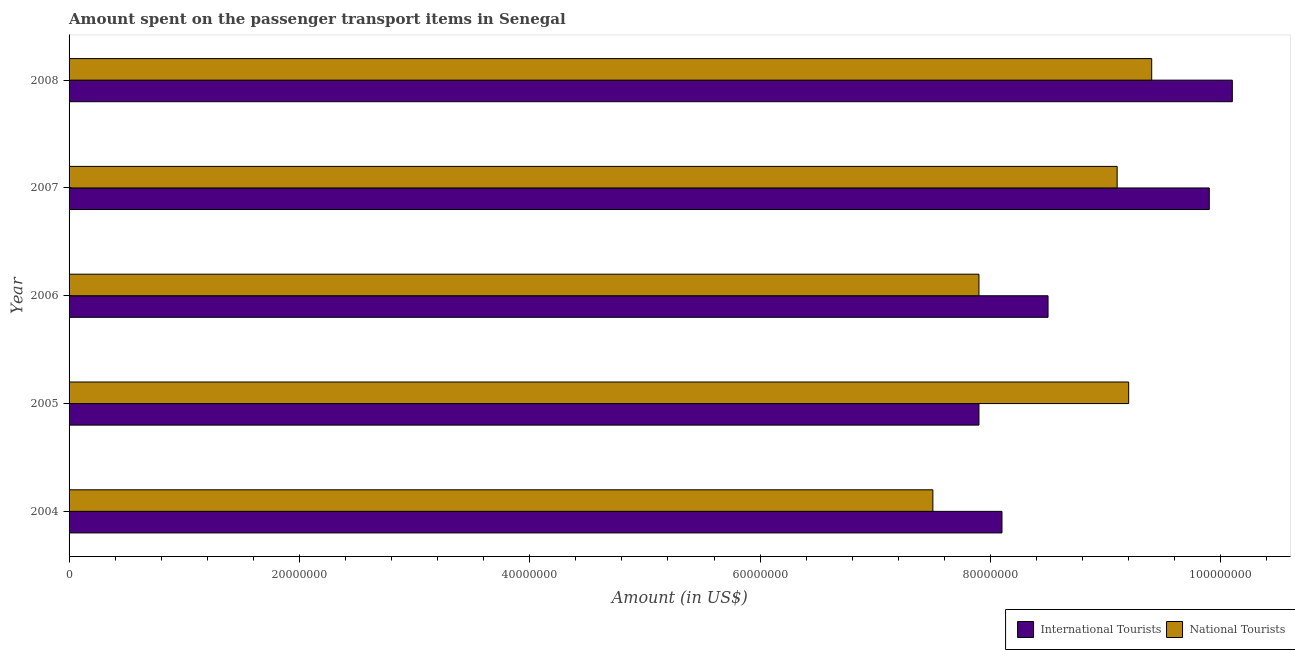How many different coloured bars are there?
Keep it short and to the point. 2. Are the number of bars per tick equal to the number of legend labels?
Keep it short and to the point. Yes. Are the number of bars on each tick of the Y-axis equal?
Make the answer very short. Yes. How many bars are there on the 1st tick from the top?
Make the answer very short. 2. What is the label of the 3rd group of bars from the top?
Offer a terse response. 2006. In how many cases, is the number of bars for a given year not equal to the number of legend labels?
Provide a succinct answer. 0. What is the amount spent on transport items of international tourists in 2006?
Provide a short and direct response. 8.50e+07. Across all years, what is the maximum amount spent on transport items of national tourists?
Provide a short and direct response. 9.40e+07. Across all years, what is the minimum amount spent on transport items of international tourists?
Give a very brief answer. 7.90e+07. In which year was the amount spent on transport items of international tourists maximum?
Keep it short and to the point. 2008. In which year was the amount spent on transport items of national tourists minimum?
Provide a succinct answer. 2004. What is the total amount spent on transport items of international tourists in the graph?
Your answer should be very brief. 4.45e+08. What is the difference between the amount spent on transport items of national tourists in 2008 and the amount spent on transport items of international tourists in 2005?
Offer a very short reply. 1.50e+07. What is the average amount spent on transport items of national tourists per year?
Offer a terse response. 8.62e+07. In the year 2006, what is the difference between the amount spent on transport items of national tourists and amount spent on transport items of international tourists?
Your answer should be very brief. -6.00e+06. In how many years, is the amount spent on transport items of national tourists greater than 12000000 US$?
Provide a succinct answer. 5. Is the amount spent on transport items of international tourists in 2005 less than that in 2006?
Keep it short and to the point. Yes. Is the difference between the amount spent on transport items of international tourists in 2004 and 2007 greater than the difference between the amount spent on transport items of national tourists in 2004 and 2007?
Make the answer very short. No. What is the difference between the highest and the lowest amount spent on transport items of national tourists?
Offer a very short reply. 1.90e+07. Is the sum of the amount spent on transport items of international tourists in 2006 and 2008 greater than the maximum amount spent on transport items of national tourists across all years?
Ensure brevity in your answer.  Yes. What does the 2nd bar from the top in 2007 represents?
Give a very brief answer. International Tourists. What does the 2nd bar from the bottom in 2008 represents?
Keep it short and to the point. National Tourists. How many years are there in the graph?
Offer a very short reply. 5. What is the difference between two consecutive major ticks on the X-axis?
Keep it short and to the point. 2.00e+07. Are the values on the major ticks of X-axis written in scientific E-notation?
Keep it short and to the point. No. Where does the legend appear in the graph?
Ensure brevity in your answer.  Bottom right. How many legend labels are there?
Provide a short and direct response. 2. What is the title of the graph?
Your answer should be compact. Amount spent on the passenger transport items in Senegal. What is the Amount (in US$) in International Tourists in 2004?
Offer a terse response. 8.10e+07. What is the Amount (in US$) of National Tourists in 2004?
Your answer should be compact. 7.50e+07. What is the Amount (in US$) in International Tourists in 2005?
Your answer should be very brief. 7.90e+07. What is the Amount (in US$) in National Tourists in 2005?
Give a very brief answer. 9.20e+07. What is the Amount (in US$) of International Tourists in 2006?
Your response must be concise. 8.50e+07. What is the Amount (in US$) of National Tourists in 2006?
Offer a terse response. 7.90e+07. What is the Amount (in US$) in International Tourists in 2007?
Your answer should be compact. 9.90e+07. What is the Amount (in US$) of National Tourists in 2007?
Offer a very short reply. 9.10e+07. What is the Amount (in US$) in International Tourists in 2008?
Ensure brevity in your answer.  1.01e+08. What is the Amount (in US$) in National Tourists in 2008?
Keep it short and to the point. 9.40e+07. Across all years, what is the maximum Amount (in US$) in International Tourists?
Ensure brevity in your answer.  1.01e+08. Across all years, what is the maximum Amount (in US$) of National Tourists?
Offer a very short reply. 9.40e+07. Across all years, what is the minimum Amount (in US$) of International Tourists?
Ensure brevity in your answer.  7.90e+07. Across all years, what is the minimum Amount (in US$) in National Tourists?
Offer a very short reply. 7.50e+07. What is the total Amount (in US$) of International Tourists in the graph?
Give a very brief answer. 4.45e+08. What is the total Amount (in US$) in National Tourists in the graph?
Provide a short and direct response. 4.31e+08. What is the difference between the Amount (in US$) of National Tourists in 2004 and that in 2005?
Provide a succinct answer. -1.70e+07. What is the difference between the Amount (in US$) in National Tourists in 2004 and that in 2006?
Your answer should be very brief. -4.00e+06. What is the difference between the Amount (in US$) in International Tourists in 2004 and that in 2007?
Make the answer very short. -1.80e+07. What is the difference between the Amount (in US$) of National Tourists in 2004 and that in 2007?
Your answer should be very brief. -1.60e+07. What is the difference between the Amount (in US$) in International Tourists in 2004 and that in 2008?
Give a very brief answer. -2.00e+07. What is the difference between the Amount (in US$) of National Tourists in 2004 and that in 2008?
Provide a succinct answer. -1.90e+07. What is the difference between the Amount (in US$) of International Tourists in 2005 and that in 2006?
Give a very brief answer. -6.00e+06. What is the difference between the Amount (in US$) of National Tourists in 2005 and that in 2006?
Your answer should be very brief. 1.30e+07. What is the difference between the Amount (in US$) in International Tourists in 2005 and that in 2007?
Your answer should be very brief. -2.00e+07. What is the difference between the Amount (in US$) of International Tourists in 2005 and that in 2008?
Ensure brevity in your answer.  -2.20e+07. What is the difference between the Amount (in US$) of National Tourists in 2005 and that in 2008?
Keep it short and to the point. -2.00e+06. What is the difference between the Amount (in US$) in International Tourists in 2006 and that in 2007?
Your answer should be compact. -1.40e+07. What is the difference between the Amount (in US$) of National Tourists in 2006 and that in 2007?
Give a very brief answer. -1.20e+07. What is the difference between the Amount (in US$) of International Tourists in 2006 and that in 2008?
Provide a short and direct response. -1.60e+07. What is the difference between the Amount (in US$) in National Tourists in 2006 and that in 2008?
Keep it short and to the point. -1.50e+07. What is the difference between the Amount (in US$) of International Tourists in 2007 and that in 2008?
Provide a succinct answer. -2.00e+06. What is the difference between the Amount (in US$) of National Tourists in 2007 and that in 2008?
Keep it short and to the point. -3.00e+06. What is the difference between the Amount (in US$) in International Tourists in 2004 and the Amount (in US$) in National Tourists in 2005?
Your answer should be compact. -1.10e+07. What is the difference between the Amount (in US$) in International Tourists in 2004 and the Amount (in US$) in National Tourists in 2006?
Make the answer very short. 2.00e+06. What is the difference between the Amount (in US$) in International Tourists in 2004 and the Amount (in US$) in National Tourists in 2007?
Offer a terse response. -1.00e+07. What is the difference between the Amount (in US$) of International Tourists in 2004 and the Amount (in US$) of National Tourists in 2008?
Provide a succinct answer. -1.30e+07. What is the difference between the Amount (in US$) in International Tourists in 2005 and the Amount (in US$) in National Tourists in 2006?
Offer a terse response. 0. What is the difference between the Amount (in US$) in International Tourists in 2005 and the Amount (in US$) in National Tourists in 2007?
Keep it short and to the point. -1.20e+07. What is the difference between the Amount (in US$) in International Tourists in 2005 and the Amount (in US$) in National Tourists in 2008?
Provide a succinct answer. -1.50e+07. What is the difference between the Amount (in US$) of International Tourists in 2006 and the Amount (in US$) of National Tourists in 2007?
Your answer should be compact. -6.00e+06. What is the difference between the Amount (in US$) in International Tourists in 2006 and the Amount (in US$) in National Tourists in 2008?
Your response must be concise. -9.00e+06. What is the difference between the Amount (in US$) of International Tourists in 2007 and the Amount (in US$) of National Tourists in 2008?
Offer a terse response. 5.00e+06. What is the average Amount (in US$) of International Tourists per year?
Your response must be concise. 8.90e+07. What is the average Amount (in US$) of National Tourists per year?
Provide a short and direct response. 8.62e+07. In the year 2004, what is the difference between the Amount (in US$) of International Tourists and Amount (in US$) of National Tourists?
Your answer should be compact. 6.00e+06. In the year 2005, what is the difference between the Amount (in US$) in International Tourists and Amount (in US$) in National Tourists?
Provide a succinct answer. -1.30e+07. What is the ratio of the Amount (in US$) of International Tourists in 2004 to that in 2005?
Your response must be concise. 1.03. What is the ratio of the Amount (in US$) in National Tourists in 2004 to that in 2005?
Your answer should be compact. 0.82. What is the ratio of the Amount (in US$) of International Tourists in 2004 to that in 2006?
Provide a succinct answer. 0.95. What is the ratio of the Amount (in US$) of National Tourists in 2004 to that in 2006?
Give a very brief answer. 0.95. What is the ratio of the Amount (in US$) in International Tourists in 2004 to that in 2007?
Keep it short and to the point. 0.82. What is the ratio of the Amount (in US$) of National Tourists in 2004 to that in 2007?
Provide a succinct answer. 0.82. What is the ratio of the Amount (in US$) in International Tourists in 2004 to that in 2008?
Provide a short and direct response. 0.8. What is the ratio of the Amount (in US$) of National Tourists in 2004 to that in 2008?
Ensure brevity in your answer.  0.8. What is the ratio of the Amount (in US$) in International Tourists in 2005 to that in 2006?
Your answer should be very brief. 0.93. What is the ratio of the Amount (in US$) of National Tourists in 2005 to that in 2006?
Provide a succinct answer. 1.16. What is the ratio of the Amount (in US$) of International Tourists in 2005 to that in 2007?
Offer a very short reply. 0.8. What is the ratio of the Amount (in US$) in National Tourists in 2005 to that in 2007?
Your answer should be very brief. 1.01. What is the ratio of the Amount (in US$) in International Tourists in 2005 to that in 2008?
Give a very brief answer. 0.78. What is the ratio of the Amount (in US$) in National Tourists in 2005 to that in 2008?
Make the answer very short. 0.98. What is the ratio of the Amount (in US$) in International Tourists in 2006 to that in 2007?
Keep it short and to the point. 0.86. What is the ratio of the Amount (in US$) of National Tourists in 2006 to that in 2007?
Give a very brief answer. 0.87. What is the ratio of the Amount (in US$) of International Tourists in 2006 to that in 2008?
Your response must be concise. 0.84. What is the ratio of the Amount (in US$) in National Tourists in 2006 to that in 2008?
Ensure brevity in your answer.  0.84. What is the ratio of the Amount (in US$) of International Tourists in 2007 to that in 2008?
Provide a succinct answer. 0.98. What is the ratio of the Amount (in US$) in National Tourists in 2007 to that in 2008?
Ensure brevity in your answer.  0.97. What is the difference between the highest and the second highest Amount (in US$) of International Tourists?
Provide a succinct answer. 2.00e+06. What is the difference between the highest and the second highest Amount (in US$) of National Tourists?
Give a very brief answer. 2.00e+06. What is the difference between the highest and the lowest Amount (in US$) of International Tourists?
Your answer should be compact. 2.20e+07. What is the difference between the highest and the lowest Amount (in US$) in National Tourists?
Provide a short and direct response. 1.90e+07. 